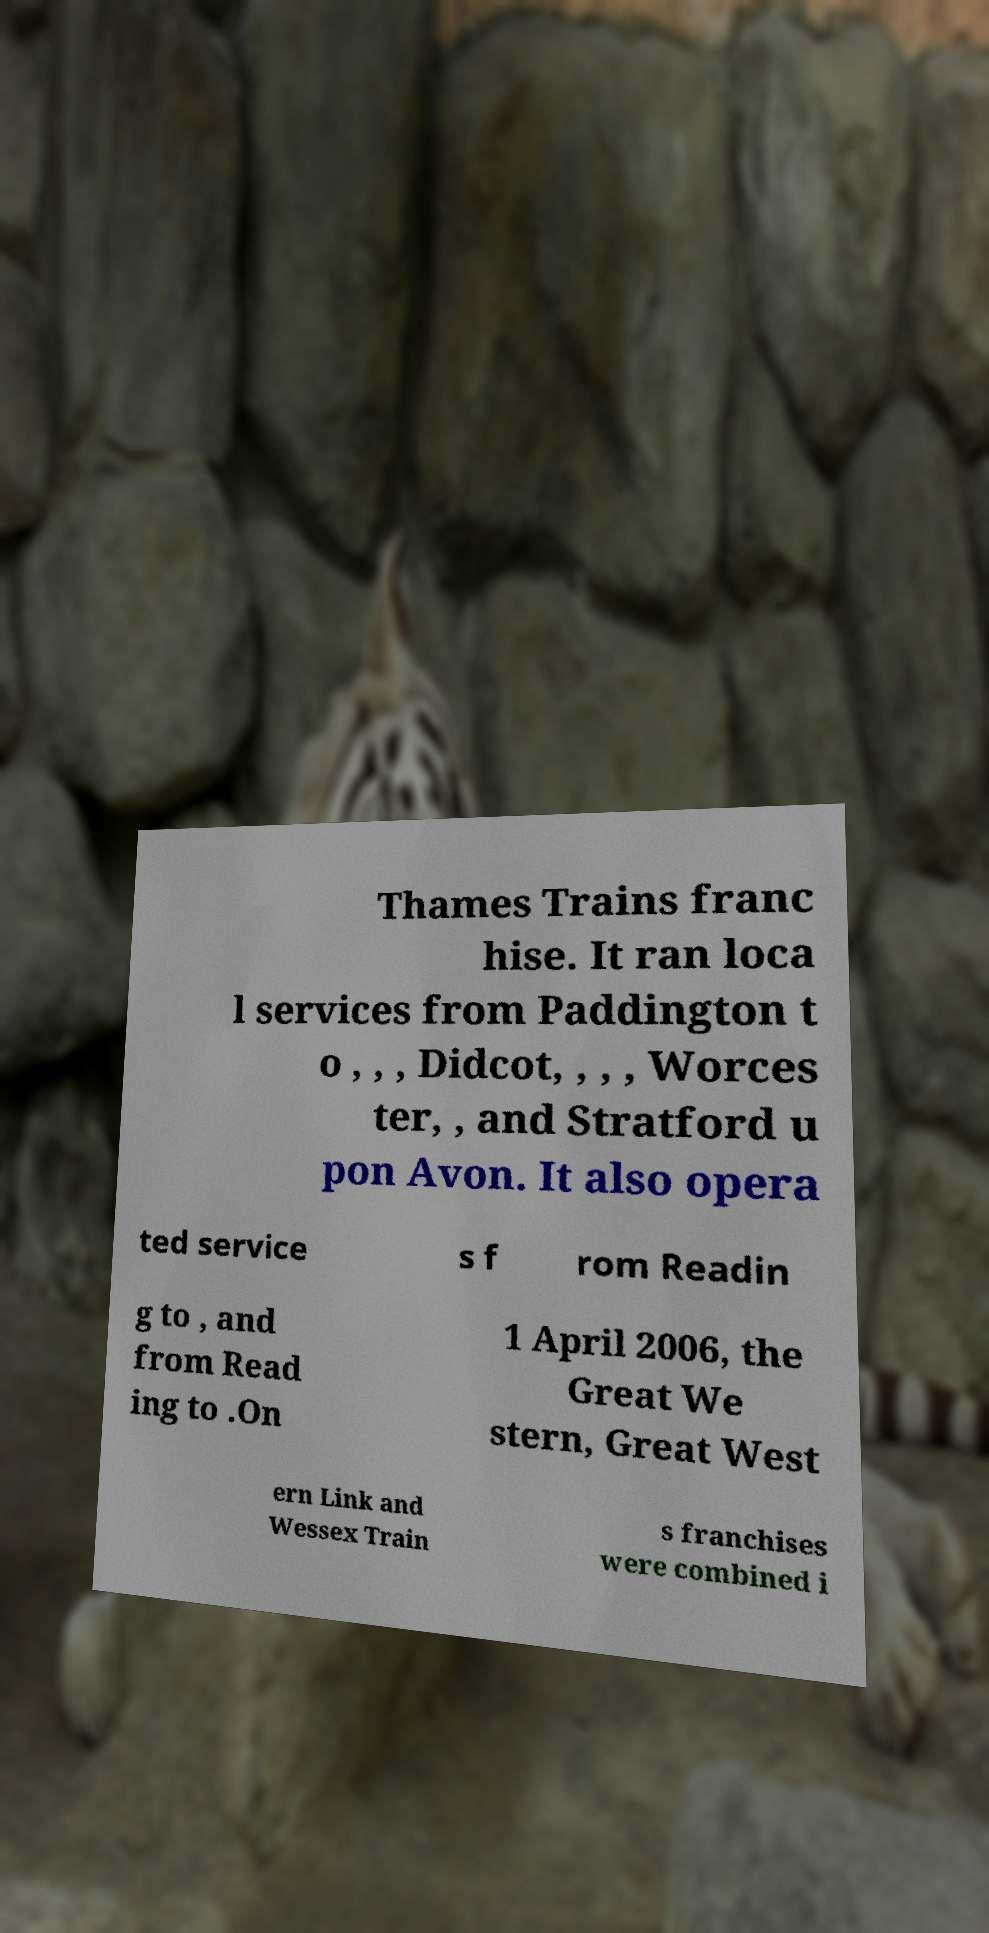There's text embedded in this image that I need extracted. Can you transcribe it verbatim? Thames Trains franc hise. It ran loca l services from Paddington t o , , , Didcot, , , , Worces ter, , and Stratford u pon Avon. It also opera ted service s f rom Readin g to , and from Read ing to .On 1 April 2006, the Great We stern, Great West ern Link and Wessex Train s franchises were combined i 